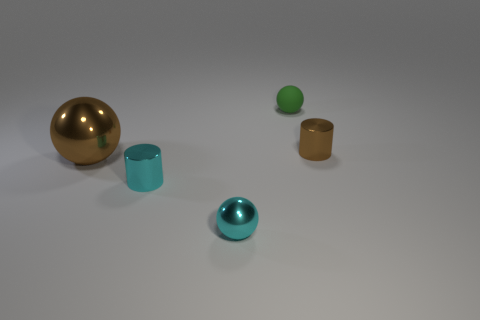Does the lighting suggest a particular time of day or location? The lighting in the image is artificial and neutral, suggesting an indoor setting with controlled lighting conditions rather than natural light that would indicate a specific time of day. 